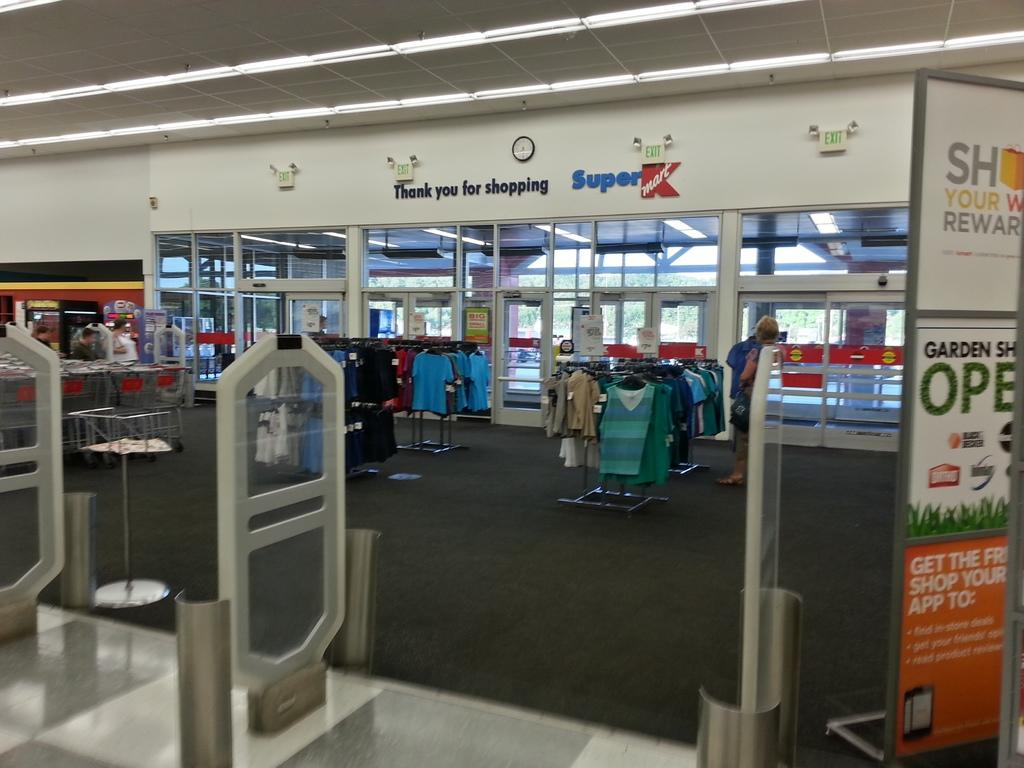<image>
Present a compact description of the photo's key features. Exit doors for a Super Kmart shopping store. 